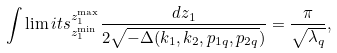<formula> <loc_0><loc_0><loc_500><loc_500>\int \lim i t s _ { z _ { 1 } ^ { \min } } ^ { z _ { 1 } ^ { \max } } \frac { d z _ { 1 } } { 2 \sqrt { - \Delta ( k _ { 1 } , k _ { 2 } , p _ { 1 q } , p _ { 2 q } } ) } = \frac { \pi } { \sqrt { \lambda _ { q } } } ,</formula> 